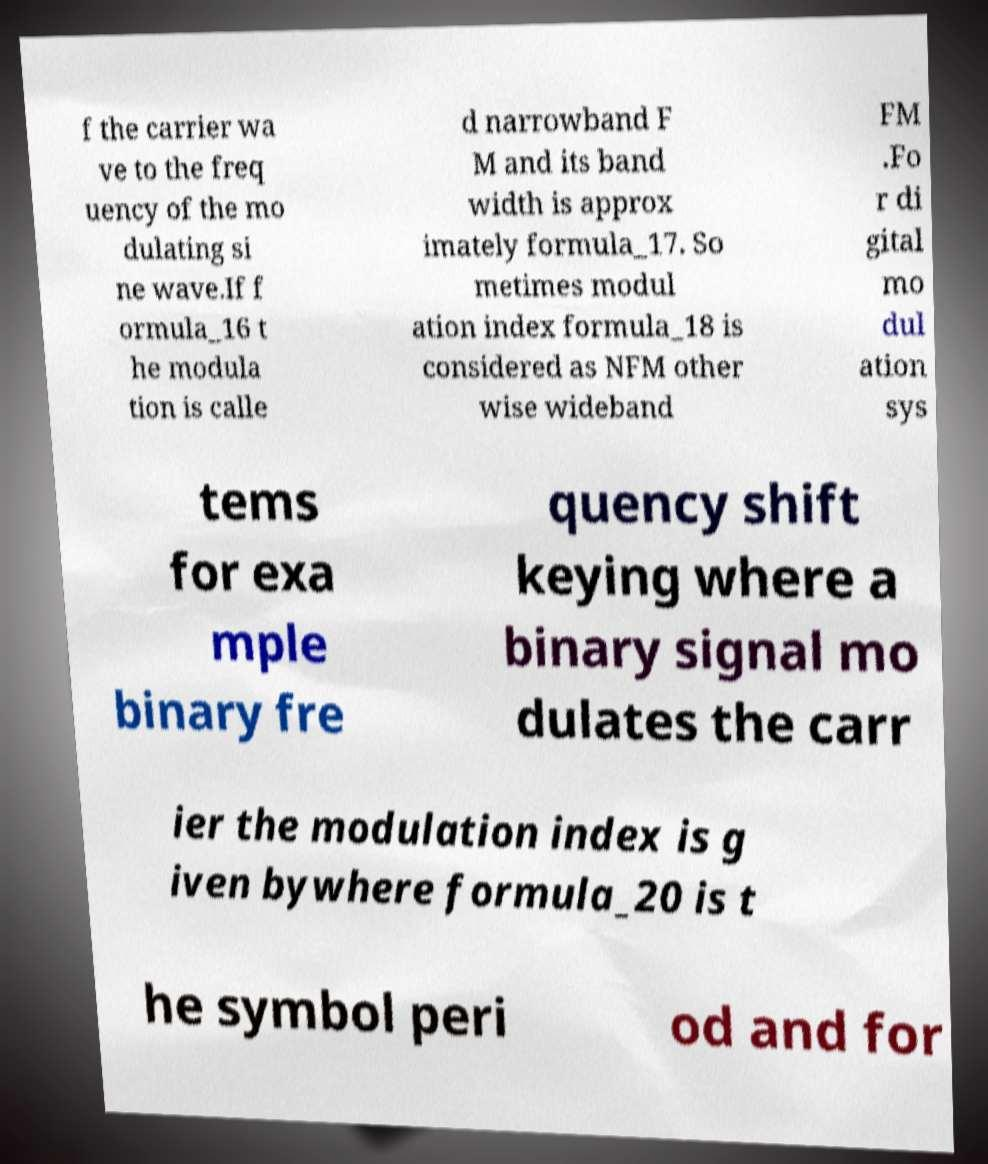Can you read and provide the text displayed in the image?This photo seems to have some interesting text. Can you extract and type it out for me? f the carrier wa ve to the freq uency of the mo dulating si ne wave.If f ormula_16 t he modula tion is calle d narrowband F M and its band width is approx imately formula_17. So metimes modul ation index formula_18 is considered as NFM other wise wideband FM .Fo r di gital mo dul ation sys tems for exa mple binary fre quency shift keying where a binary signal mo dulates the carr ier the modulation index is g iven bywhere formula_20 is t he symbol peri od and for 